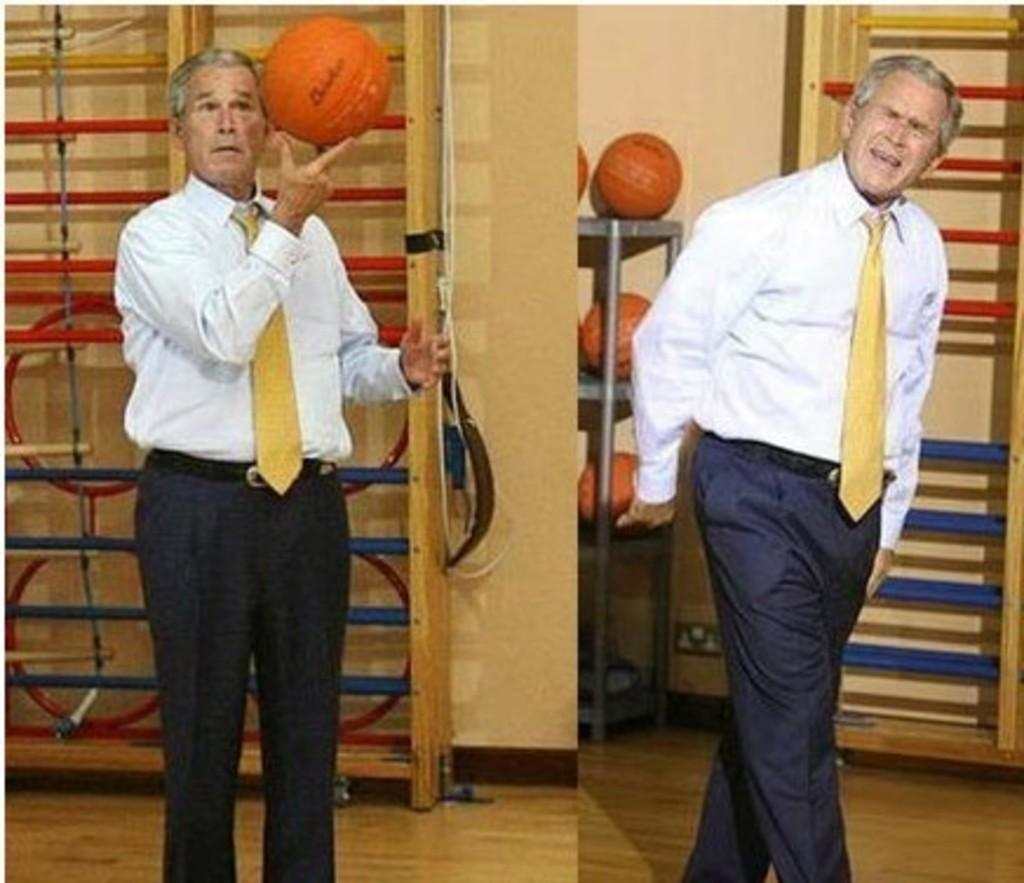Who is present in the image? There is a man in the image. What is the man wearing? The man is wearing a white shirt. What activity is the man engaged in? The man is playing with a ball. What can be seen in the background of the image? There is a wall and objects in the background of the image. What is the relationship between the man and the objects in the background? The objects in the background are likely related to the man's activity, as there are balls in and on the racks. What type of vegetable is the man using to play with the ball in the image? There is no vegetable present in the image, and the man is playing with a ball, not a vegetable. 